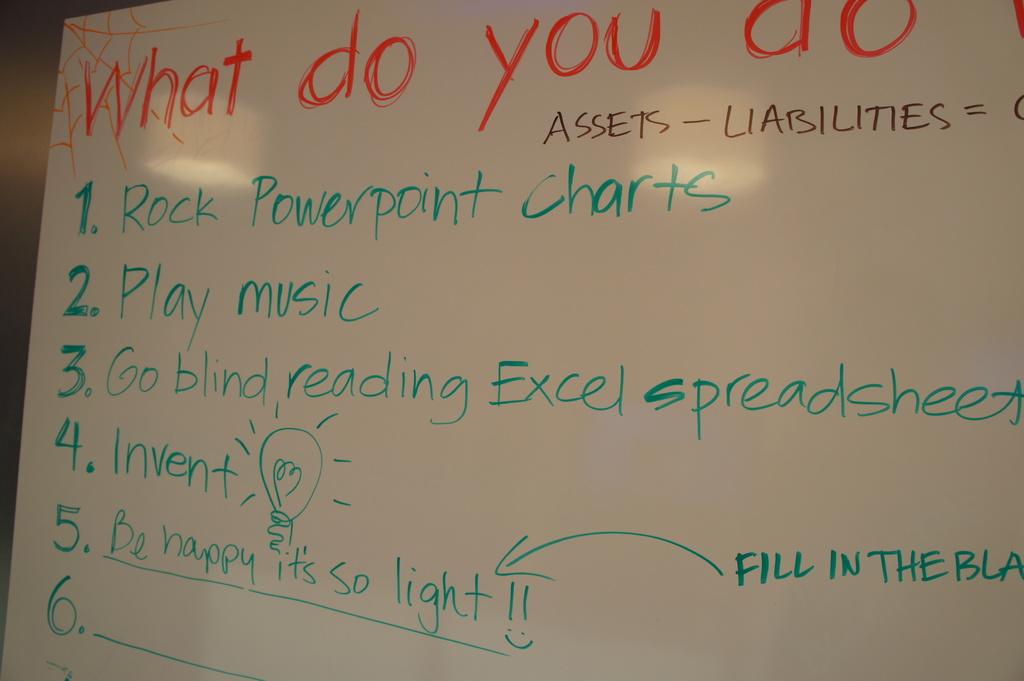What are the words in red?
Provide a short and direct response. What do you do. Assets minus what?
Your response must be concise. Liabilities. 